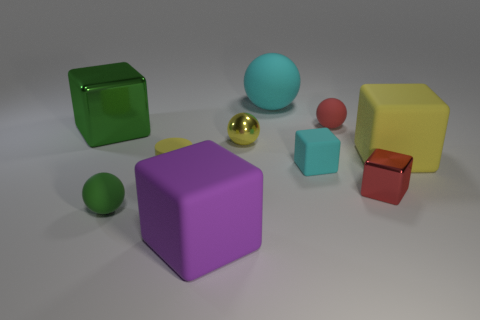Are the small red block and the cyan object behind the big yellow rubber cube made of the same material?
Your response must be concise. No. What color is the tiny rubber block?
Keep it short and to the point. Cyan. There is a large block in front of the small rubber ball that is in front of the tiny red ball; what number of green shiny blocks are behind it?
Your answer should be very brief. 1. Are there any big cyan things to the left of the small yellow matte object?
Give a very brief answer. No. What number of tiny cylinders have the same material as the big ball?
Keep it short and to the point. 1. What number of objects are either red cylinders or red metallic objects?
Offer a very short reply. 1. Is there a red metal cube?
Provide a short and direct response. Yes. What material is the tiny red thing that is in front of the tiny yellow object that is in front of the tiny cube on the left side of the tiny red shiny block?
Your answer should be very brief. Metal. Are there fewer big purple cubes that are behind the tiny cyan object than large cyan metallic cubes?
Offer a very short reply. No. What material is the red sphere that is the same size as the cyan cube?
Keep it short and to the point. Rubber. 